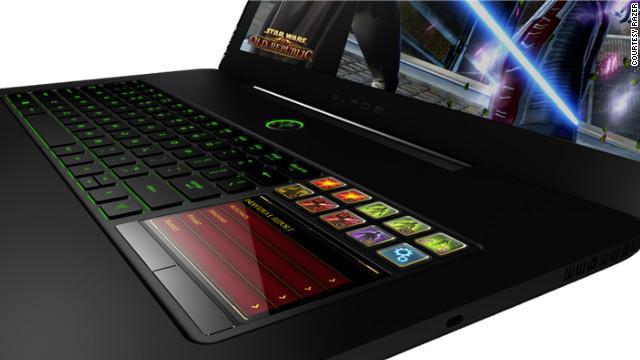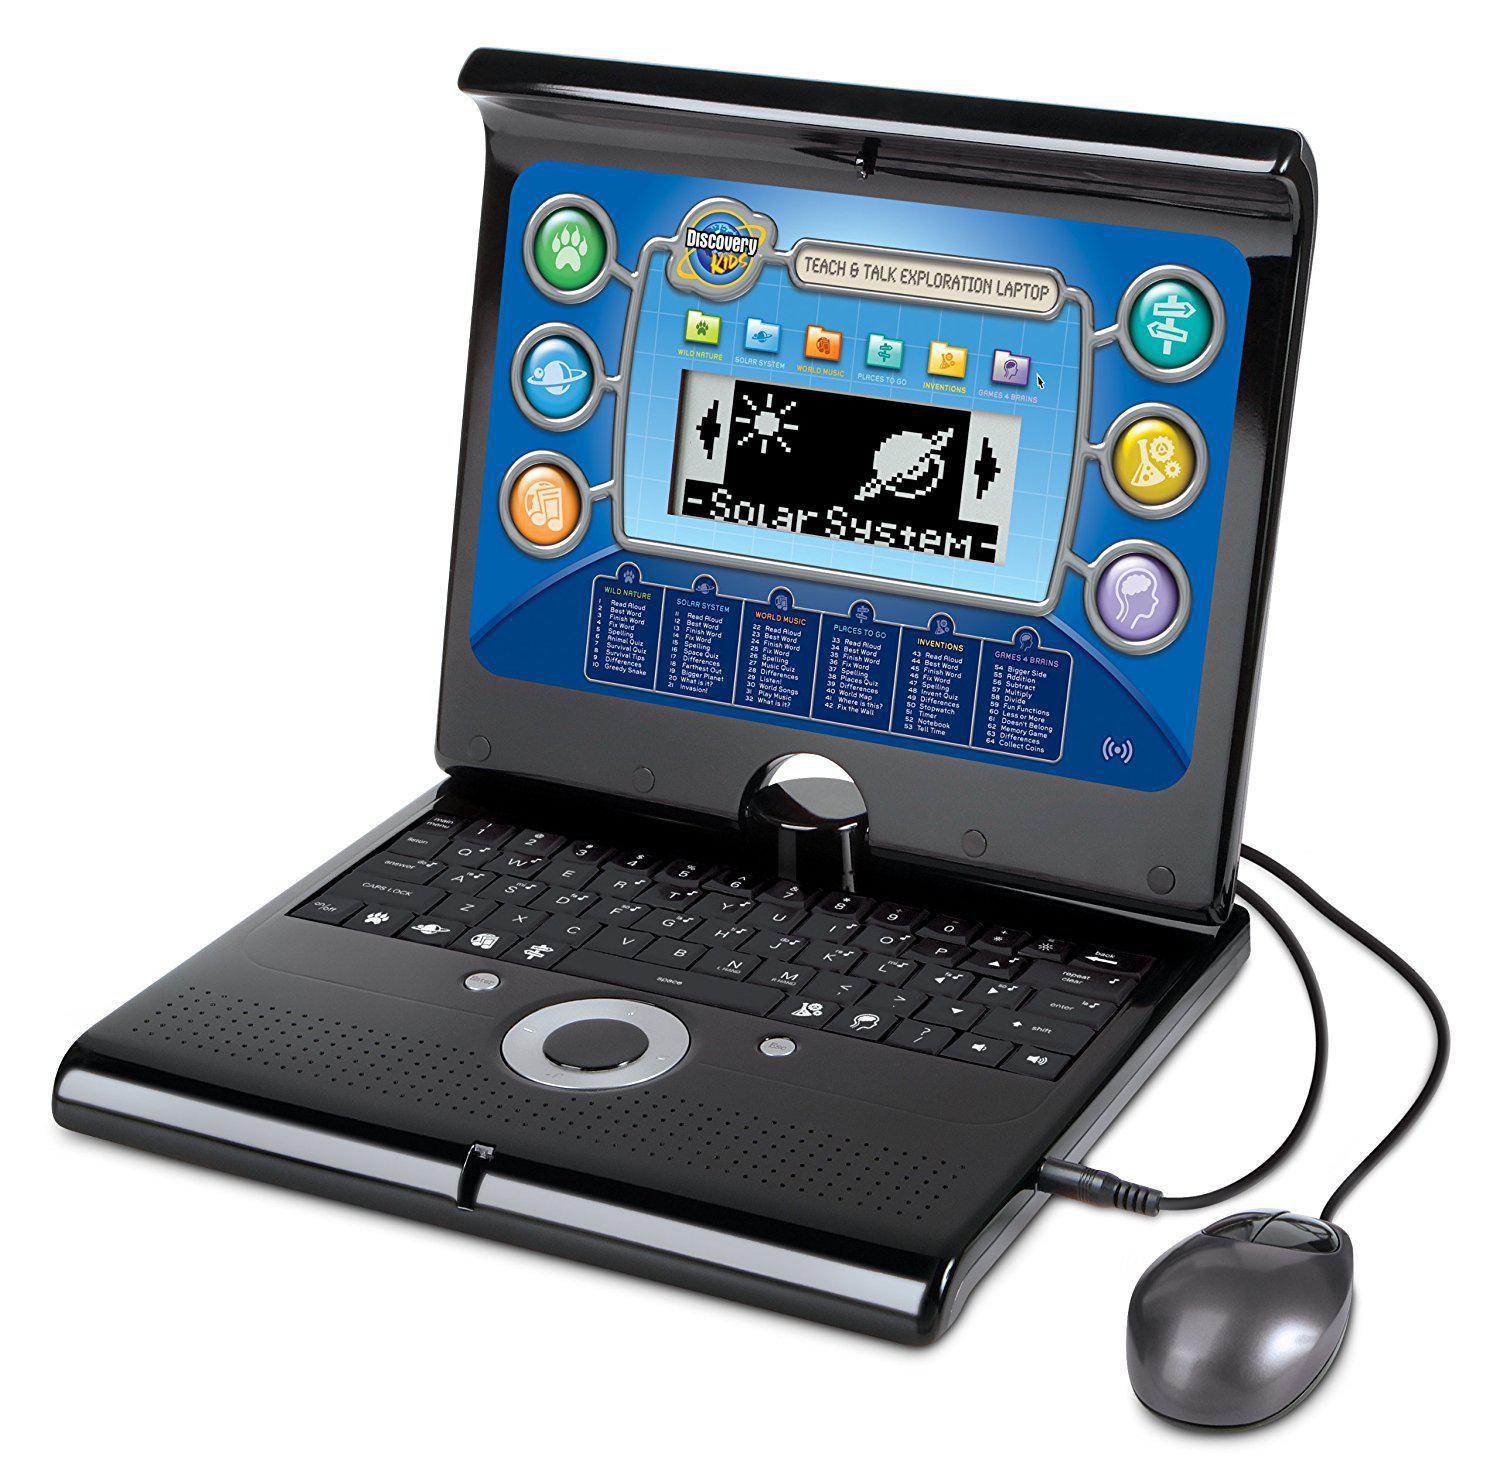The first image is the image on the left, the second image is the image on the right. Considering the images on both sides, is "A mouse is connected to the computer on the right." valid? Answer yes or no. Yes. The first image is the image on the left, the second image is the image on the right. Assess this claim about the two images: "An image includes a laptop that is facing directly forward.". Correct or not? Answer yes or no. No. 